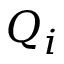Convert formula to latex. <formula><loc_0><loc_0><loc_500><loc_500>Q _ { i }</formula> 